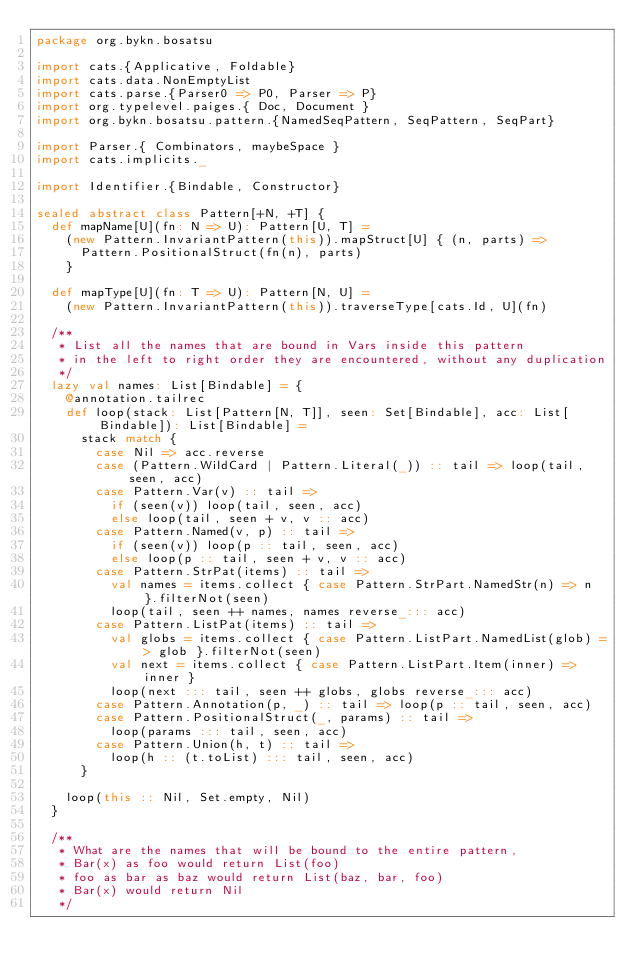Convert code to text. <code><loc_0><loc_0><loc_500><loc_500><_Scala_>package org.bykn.bosatsu

import cats.{Applicative, Foldable}
import cats.data.NonEmptyList
import cats.parse.{Parser0 => P0, Parser => P}
import org.typelevel.paiges.{ Doc, Document }
import org.bykn.bosatsu.pattern.{NamedSeqPattern, SeqPattern, SeqPart}

import Parser.{ Combinators, maybeSpace }
import cats.implicits._

import Identifier.{Bindable, Constructor}

sealed abstract class Pattern[+N, +T] {
  def mapName[U](fn: N => U): Pattern[U, T] =
    (new Pattern.InvariantPattern(this)).mapStruct[U] { (n, parts) =>
      Pattern.PositionalStruct(fn(n), parts)
    }

  def mapType[U](fn: T => U): Pattern[N, U] =
    (new Pattern.InvariantPattern(this)).traverseType[cats.Id, U](fn)

  /**
   * List all the names that are bound in Vars inside this pattern
   * in the left to right order they are encountered, without any duplication
   */
  lazy val names: List[Bindable] = {
    @annotation.tailrec
    def loop(stack: List[Pattern[N, T]], seen: Set[Bindable], acc: List[Bindable]): List[Bindable] =
      stack match {
        case Nil => acc.reverse
        case (Pattern.WildCard | Pattern.Literal(_)) :: tail => loop(tail, seen, acc)
        case Pattern.Var(v) :: tail =>
          if (seen(v)) loop(tail, seen, acc)
          else loop(tail, seen + v, v :: acc)
        case Pattern.Named(v, p) :: tail =>
          if (seen(v)) loop(p :: tail, seen, acc)
          else loop(p :: tail, seen + v, v :: acc)
        case Pattern.StrPat(items) :: tail =>
          val names = items.collect { case Pattern.StrPart.NamedStr(n) => n }.filterNot(seen)
          loop(tail, seen ++ names, names reverse_::: acc)
        case Pattern.ListPat(items) :: tail =>
          val globs = items.collect { case Pattern.ListPart.NamedList(glob) => glob }.filterNot(seen)
          val next = items.collect { case Pattern.ListPart.Item(inner) => inner }
          loop(next ::: tail, seen ++ globs, globs reverse_::: acc)
        case Pattern.Annotation(p, _) :: tail => loop(p :: tail, seen, acc)
        case Pattern.PositionalStruct(_, params) :: tail =>
          loop(params ::: tail, seen, acc)
        case Pattern.Union(h, t) :: tail =>
          loop(h :: (t.toList) ::: tail, seen, acc)
      }

    loop(this :: Nil, Set.empty, Nil)
  }

  /**
   * What are the names that will be bound to the entire pattern,
   * Bar(x) as foo would return List(foo)
   * foo as bar as baz would return List(baz, bar, foo)
   * Bar(x) would return Nil
   */</code> 